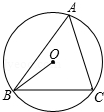In the given figure, if angle A is the angle of circumference of circle O and is represented by the variable 'x' (x = 50.0), what is the measure of angle OBC? Express the angle as 'y' in terms of 'x'. To determine the measure of angle OBC in the circle, we need to understand the fundamental properties of circle geometry. For the angle at the center (OBC) and the angle at the circumference (A), the angle at the center is twice the angle at the circumference. Given that angle A is 50 degrees (x = 50), angle OBC's measure would be 2x, equating to 100 degrees. Thus, the correct measure of angle OBC 'y' in terms of 'x' is 100 degrees. 